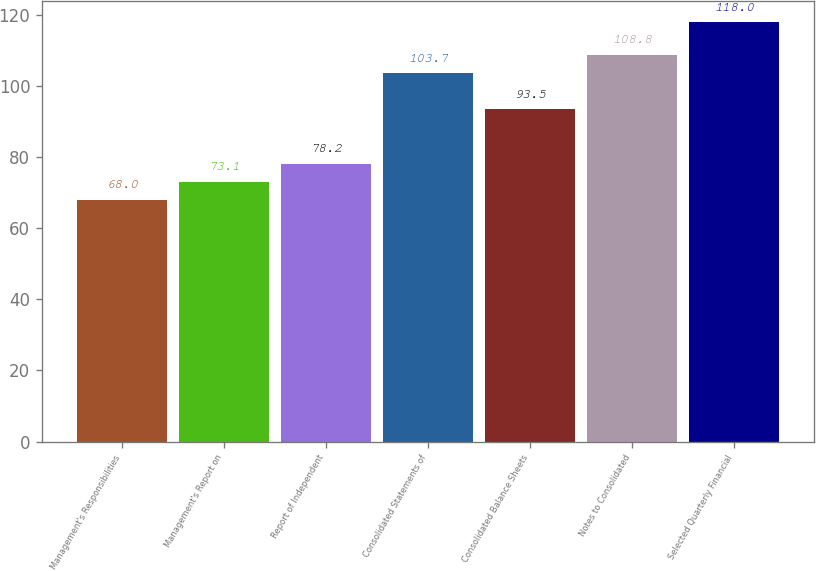<chart> <loc_0><loc_0><loc_500><loc_500><bar_chart><fcel>Management's Responsibilities<fcel>Management's Report on<fcel>Report of Independent<fcel>Consolidated Statements of<fcel>Consolidated Balance Sheets<fcel>Notes to Consolidated<fcel>Selected Quarterly Financial<nl><fcel>68<fcel>73.1<fcel>78.2<fcel>103.7<fcel>93.5<fcel>108.8<fcel>118<nl></chart> 